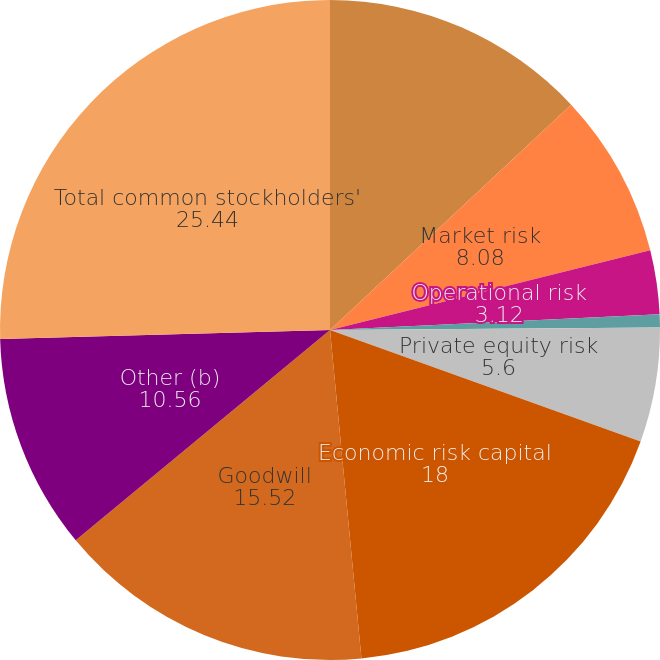<chart> <loc_0><loc_0><loc_500><loc_500><pie_chart><fcel>Credit risk<fcel>Market risk<fcel>Operational risk<fcel>Business risk<fcel>Private equity risk<fcel>Economic risk capital<fcel>Goodwill<fcel>Other (b)<fcel>Total common stockholders'<nl><fcel>13.04%<fcel>8.08%<fcel>3.12%<fcel>0.64%<fcel>5.6%<fcel>18.0%<fcel>15.52%<fcel>10.56%<fcel>25.44%<nl></chart> 